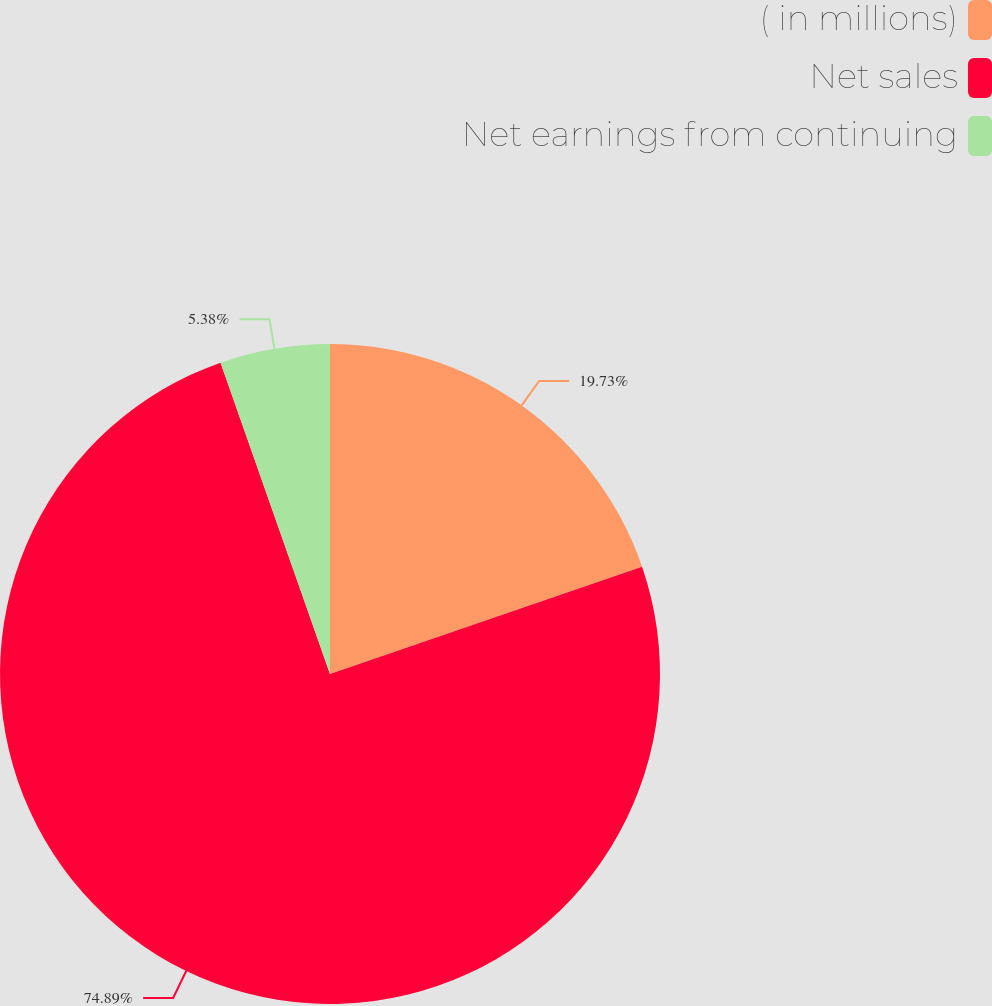<chart> <loc_0><loc_0><loc_500><loc_500><pie_chart><fcel>( in millions)<fcel>Net sales<fcel>Net earnings from continuing<nl><fcel>19.73%<fcel>74.89%<fcel>5.38%<nl></chart> 